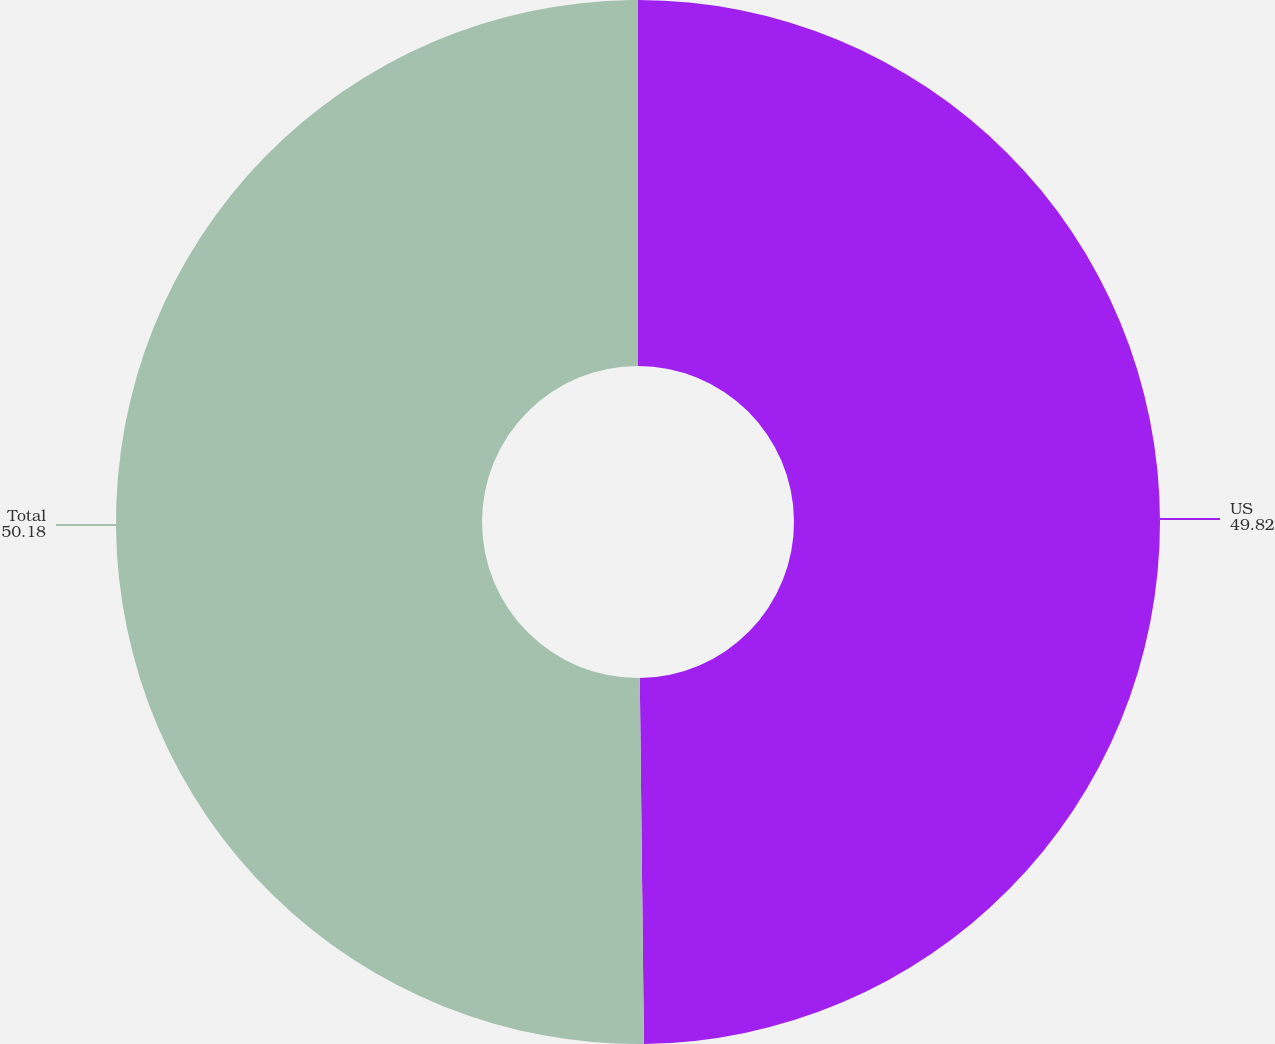<chart> <loc_0><loc_0><loc_500><loc_500><pie_chart><fcel>US<fcel>Total<nl><fcel>49.82%<fcel>50.18%<nl></chart> 